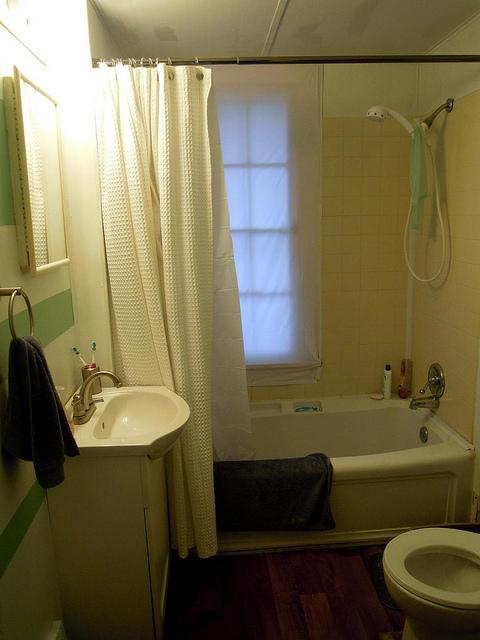What color are the stripes on the side of the bathroom wall? Please explain your reasoning. green. The stripes on the wall are green pastel. 